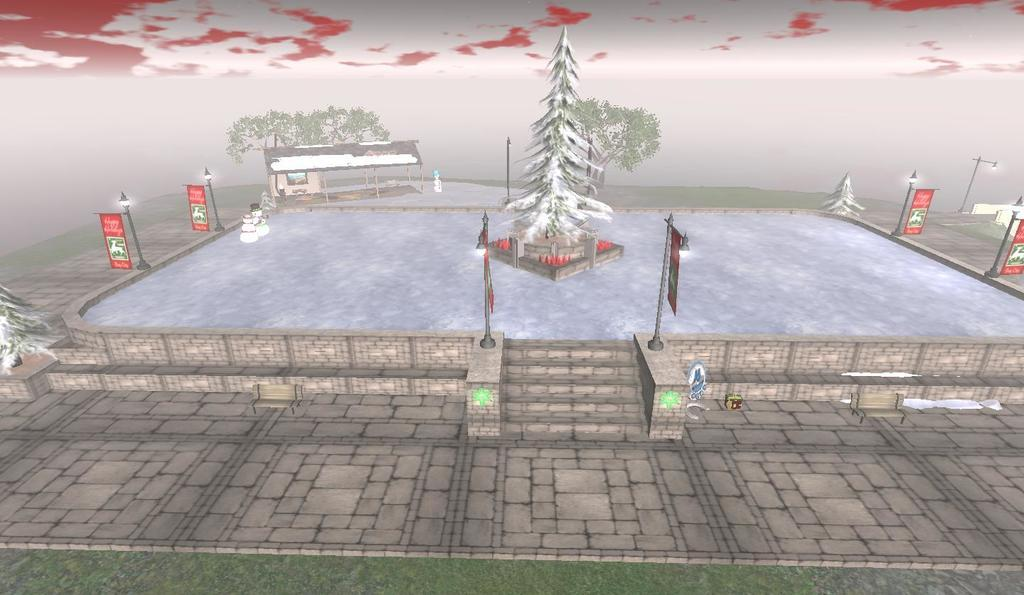What type of image is being described? The image is a graphical picture. What can be seen on the ground in the image? There is ground visible in the image, and grass is present. What other natural elements are visible in the image? Trees are visible in the image. What man-made structures can be seen in the image? Poles and a shelter are present in the image. Are there any decorative or informative elements in the image? Posters are visible in the image. What season might the image represent? The presence of snowmen suggests that the image represents a winter scene. What else is visible in the image? There are some objects in the image. What can be seen in the background of the image? The sky is visible in the background of the image. How many beans are scattered around the snowmen in the image? There are no beans present in the image; it features snowmen and other elements mentioned in the facts. 